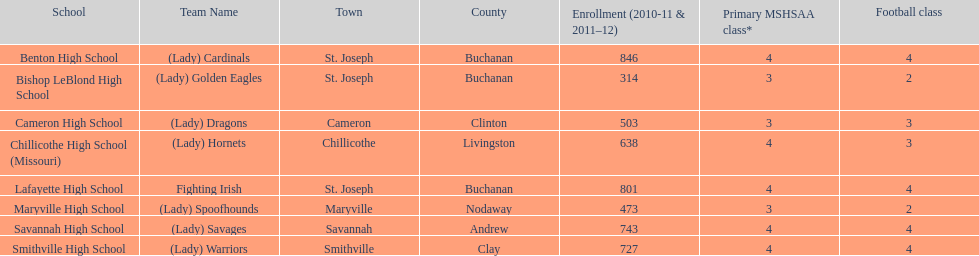How many teams have bird-inspired names? 2. 